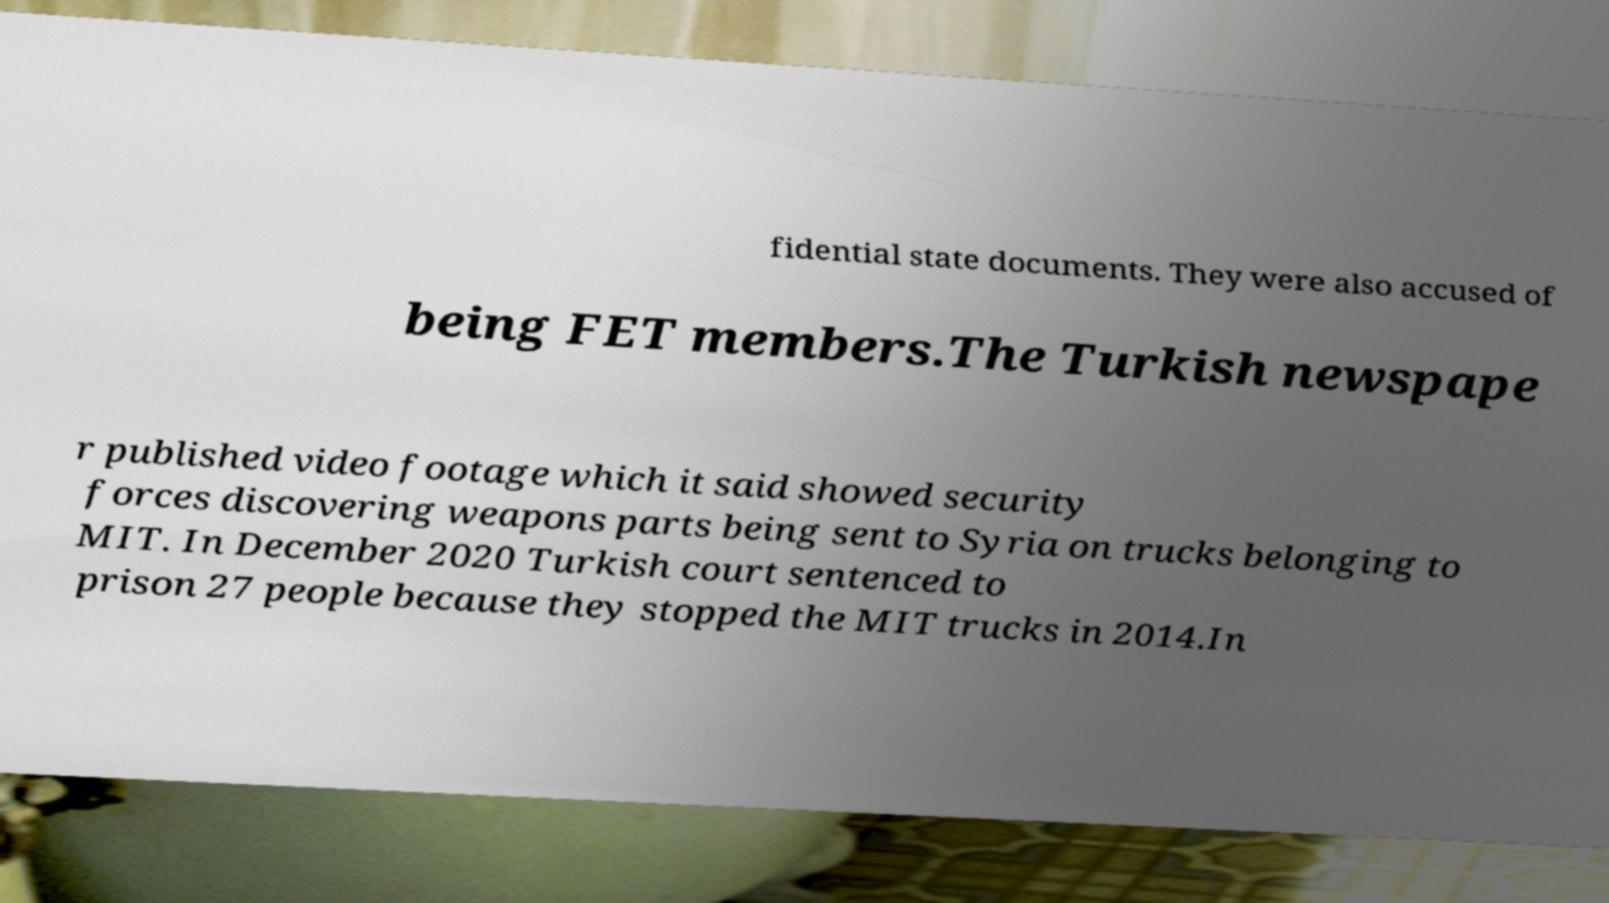Please identify and transcribe the text found in this image. fidential state documents. They were also accused of being FET members.The Turkish newspape r published video footage which it said showed security forces discovering weapons parts being sent to Syria on trucks belonging to MIT. In December 2020 Turkish court sentenced to prison 27 people because they stopped the MIT trucks in 2014.In 